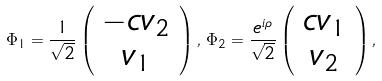<formula> <loc_0><loc_0><loc_500><loc_500>\Phi _ { 1 } = \frac { 1 } { \sqrt { 2 } } \left ( \begin{array} { c } - c v _ { 2 } \\ v _ { 1 } \end{array} \right ) , \, \Phi _ { 2 } = \frac { e ^ { i \rho } } { \sqrt { 2 } } \left ( \begin{array} { c } c v _ { 1 } \\ v _ { 2 } \end{array} \right ) ,</formula> 